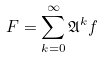<formula> <loc_0><loc_0><loc_500><loc_500>F = \sum _ { k = 0 } ^ { \infty } \mathfrak { A } ^ { k } f</formula> 